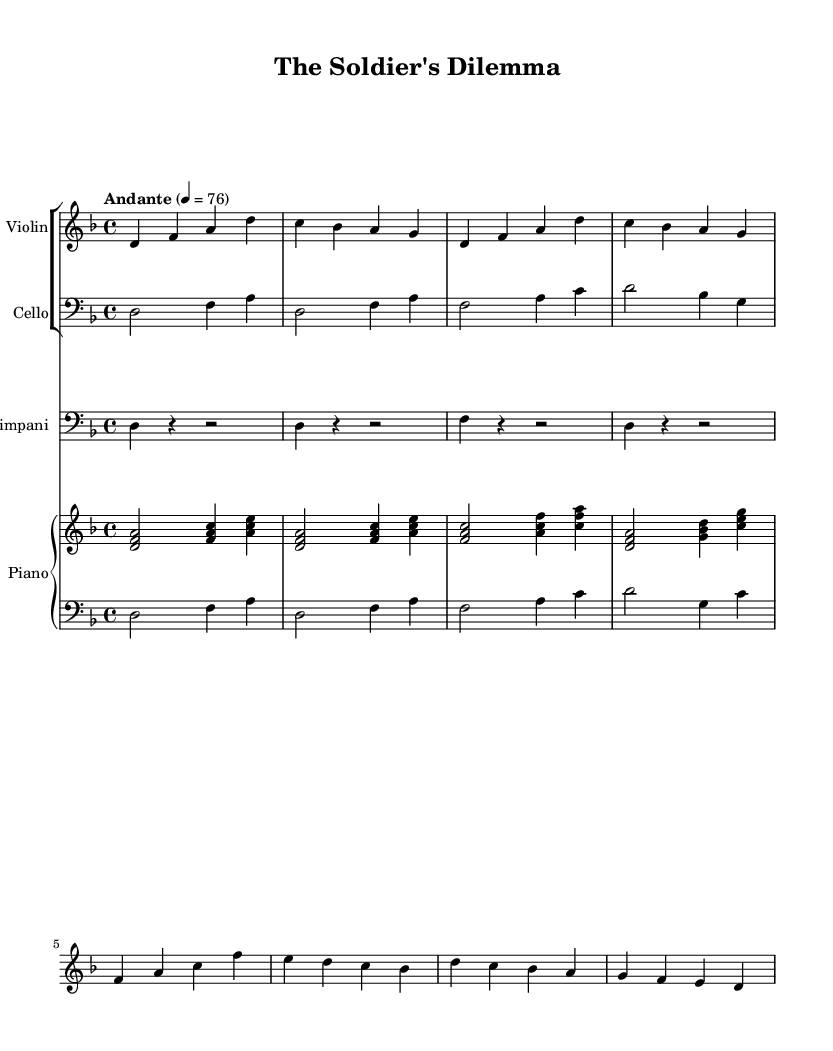what is the key signature of this music? The key signature indicated in the global settings is D minor, which is characterized by one flat (B flat).
Answer: D minor what is the time signature of this music? The time signature is indicated as 4/4 in the global settings, meaning there are four beats in each measure and the quarter note gets one beat.
Answer: 4/4 what is the tempo marking of this music? The tempo marking in the global settings is "Andante," which is a moderate pace indicating a walking speed for the music.
Answer: Andante how many measures are in the intro section? The intro contains four measures, as indicated by the four line segments in the music notation that show when the intro begins and ends.
Answer: 4 which instrument plays the first part of the chorus? The violin is the instrument that plays the first part of the chorus, as seen clearly in the musical notation for the chorus section.
Answer: Violin how does the cello contribute to the overall harmony in the first verse? The cello plays sustained notes in the first verse, providing a harmonic foundation alongside the melodic lines of the violin and piano, which supports the overall structure of the piece.
Answer: Sustained notes what is the relationship between the timpani and the other instruments in the score? The timpani provides rhythmic emphasis during transitions by playing short, accented notes that enhance the dynamics and drive of the music, complementing the melodic lines.
Answer: Rhythmic emphasis 